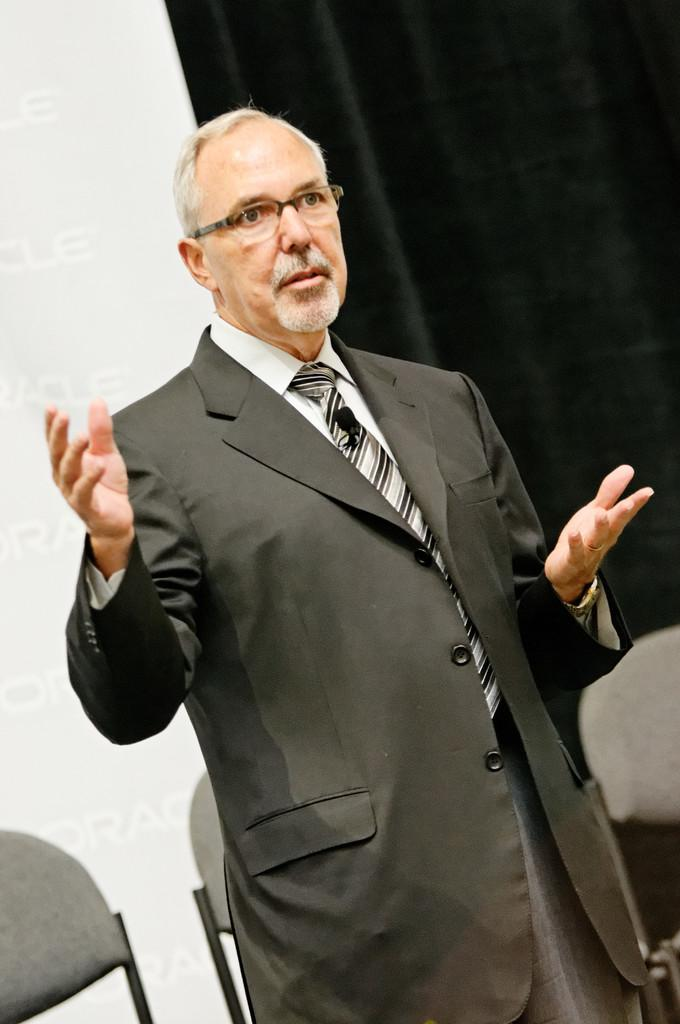What is the main subject of the image? There is a person in the image. What is the person wearing? The person is wearing a black suit. What is the person doing in the image? The person is standing and speaking. How many chairs are visible behind the person? There are two chairs behind the person. What else can be seen in the background of the image? There are other objects in the background of the image. Can you see a knife being used by the person in the image? There is no knife visible in the image, nor is the person using one. What type of flower is on the person's lapel in the image? There is no flower visible on the person's lapel in the image. 